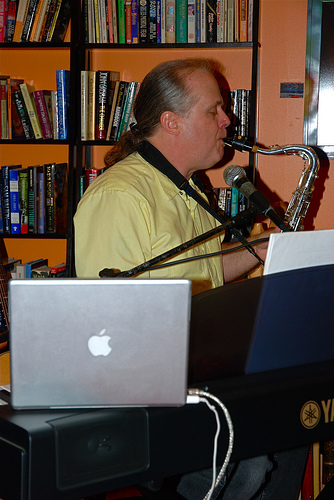<image>
Is the saxophone in the shelf? No. The saxophone is not contained within the shelf. These objects have a different spatial relationship. 